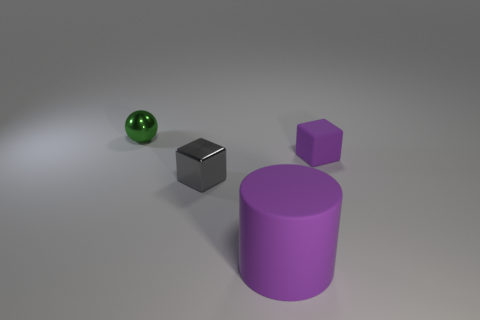Is there any other thing that is the same size as the purple rubber cylinder?
Ensure brevity in your answer.  No. What is the size of the metallic object that is left of the metallic object that is on the right side of the small green ball?
Provide a succinct answer. Small. There is a thing that is to the left of the small gray metal cube; what material is it?
Ensure brevity in your answer.  Metal. How many objects are either small metal things in front of the tiny green ball or metallic things in front of the tiny rubber block?
Offer a very short reply. 1. What is the material of the other tiny gray thing that is the same shape as the small rubber thing?
Offer a terse response. Metal. Is the color of the rubber object that is behind the cylinder the same as the matte object to the left of the tiny matte thing?
Offer a very short reply. Yes. Is there a cyan matte thing that has the same size as the gray cube?
Make the answer very short. No. What is the thing that is in front of the tiny purple cube and to the left of the rubber cylinder made of?
Offer a terse response. Metal. What number of rubber objects are purple cubes or red spheres?
Your answer should be very brief. 1. The gray object that is the same material as the small green sphere is what shape?
Give a very brief answer. Cube. 